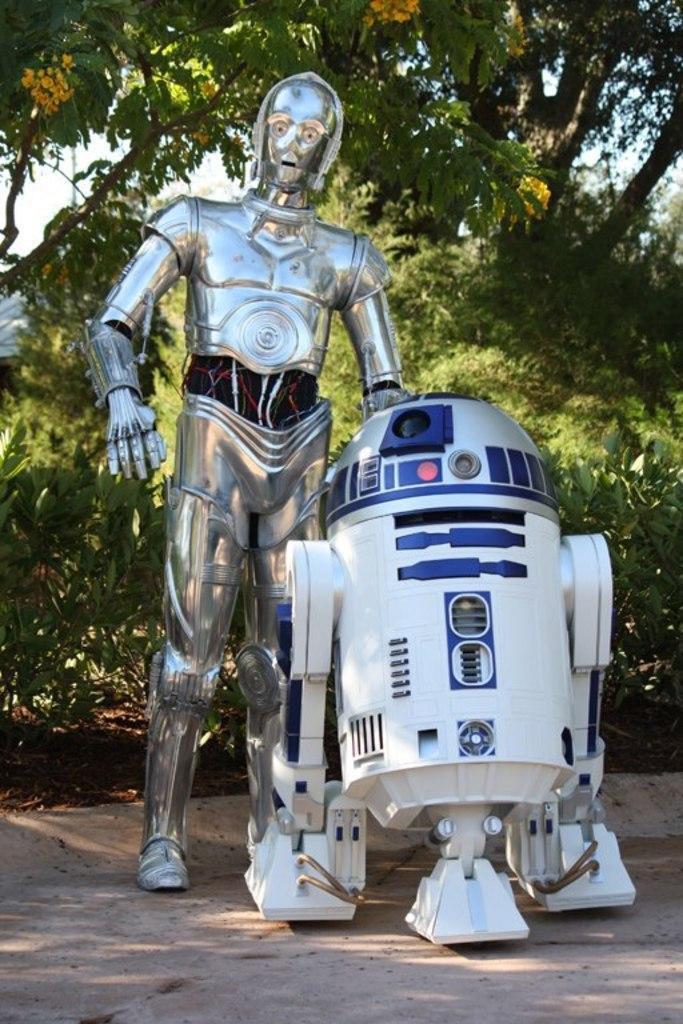Please provide a concise description of this image. In this picture we can see a robot and there is a machine. This is the road. And on the background there are many trees, these are the yellow colored flowers. And there is a sky. 